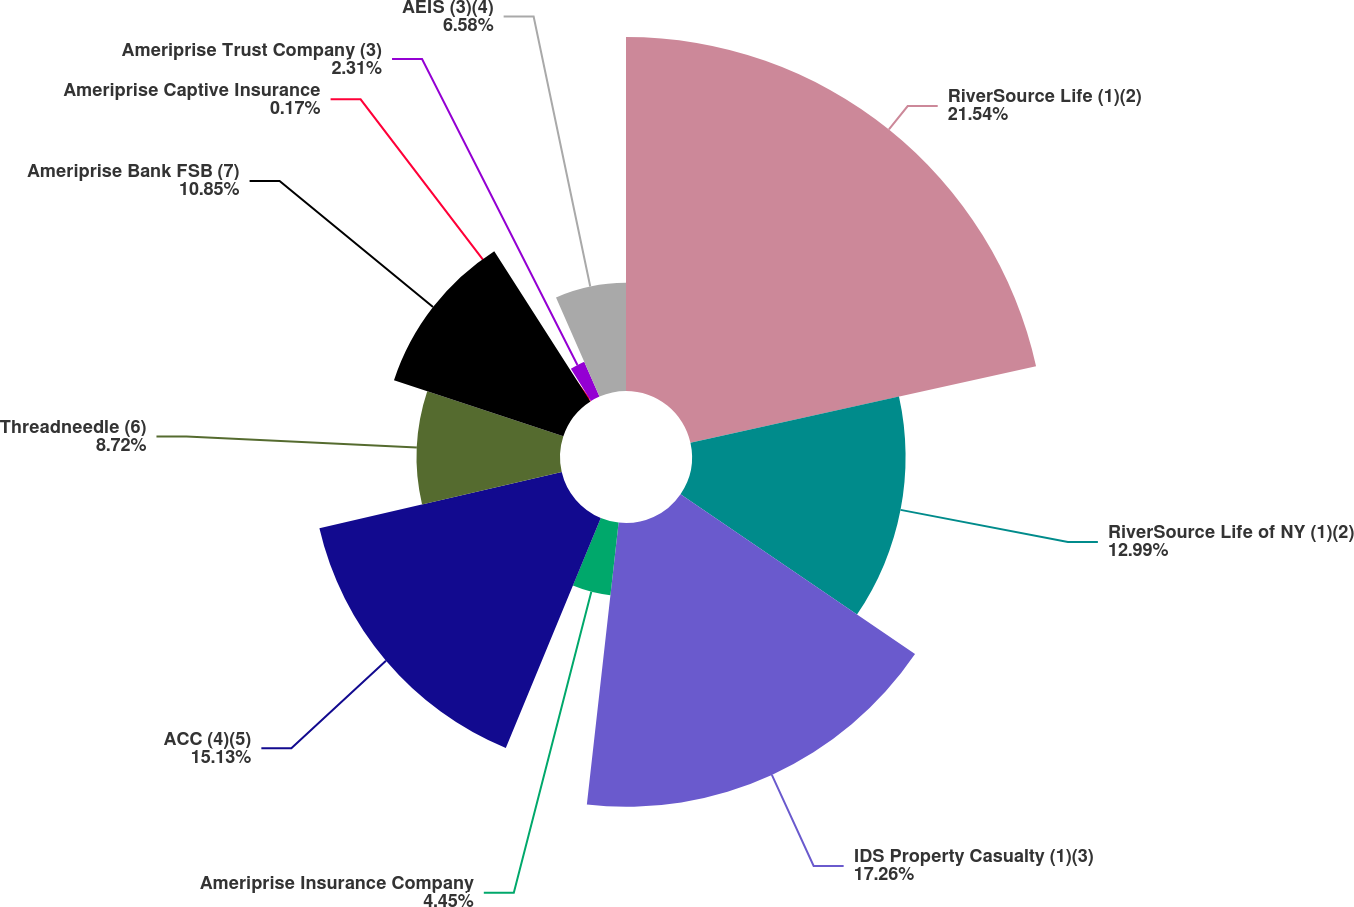Convert chart. <chart><loc_0><loc_0><loc_500><loc_500><pie_chart><fcel>RiverSource Life (1)(2)<fcel>RiverSource Life of NY (1)(2)<fcel>IDS Property Casualty (1)(3)<fcel>Ameriprise Insurance Company<fcel>ACC (4)(5)<fcel>Threadneedle (6)<fcel>Ameriprise Bank FSB (7)<fcel>Ameriprise Captive Insurance<fcel>Ameriprise Trust Company (3)<fcel>AEIS (3)(4)<nl><fcel>21.53%<fcel>12.99%<fcel>17.26%<fcel>4.45%<fcel>15.13%<fcel>8.72%<fcel>10.85%<fcel>0.17%<fcel>2.31%<fcel>6.58%<nl></chart> 